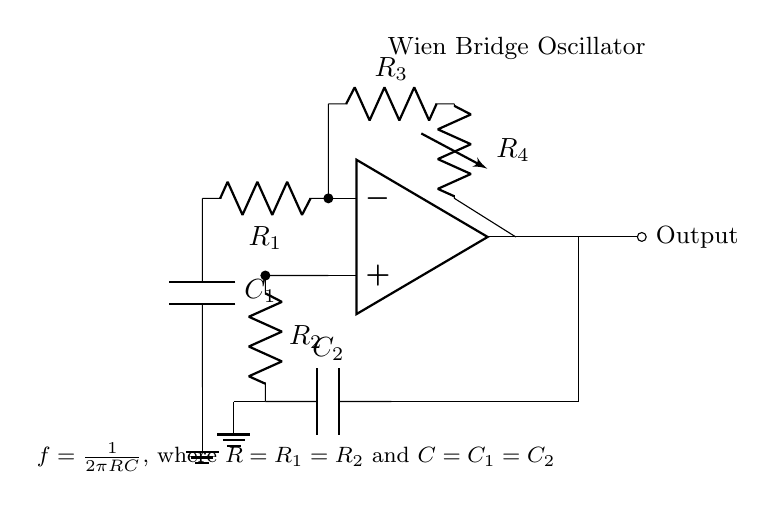What type of oscillator is shown in the circuit? The circuit is identified as a Wien Bridge Oscillator, which is characterized by its specific arrangement of resistors and capacitors to produce sine waves.
Answer: Wien Bridge Oscillator How many capacitors are present in the circuit? The diagram includes two capacitors in the configuration, labeled C1 and C2, which are necessary for generating oscillation frequencies.
Answer: 2 What is the frequency formula given in the circuit? The circuit shows the frequency equation: f = 1/(2πRC), indicating the dependency on resistance and capacitance for oscillation frequency.
Answer: f = 1/(2πRC) What role does the variable resistor play in the circuit? The variable resistor, labeled R4, is used for gain control in the oscillator, helping to stabilize oscillations and prevent distortion.
Answer: Gain control What is the output connection in the circuit? The output of the circuit is connected to a node labeled 'Output', which is the signal point that delivers the generated sine waves.
Answer: Output What condition must be met for the Wien Bridge Oscillator to operate properly? The condition for operation is that the gain of the amplifier must equal one when the circuit reaches stability; hence the resistance needs proper adjustment for oscillation.
Answer: Gain equals one What happens if R1 and R2 are not equal? If R1 and R2 are unequal, the frequency calculation would be inaccurate, affecting the stability and performance of the sinusoidal output.
Answer: Frequency error 